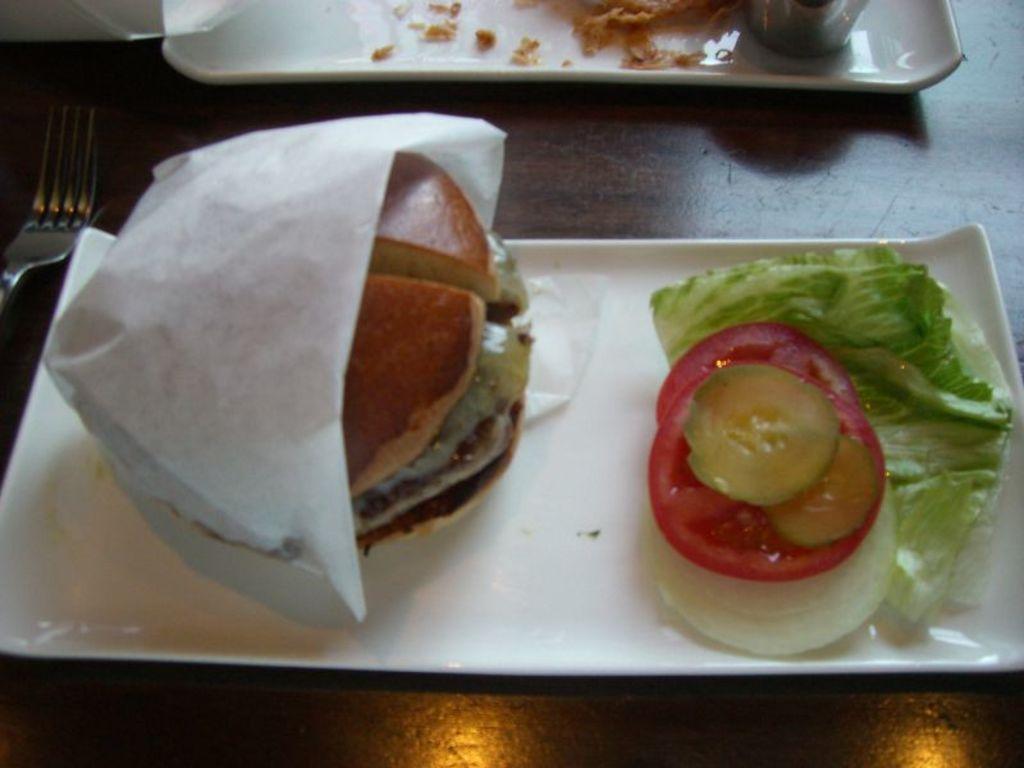In one or two sentences, can you explain what this image depicts? In this picture, we see a brown table on which a tray containing burger, tissue paper, tomato are placed on the table. We even see fork and a tray containing food and glass are placed on that table. 